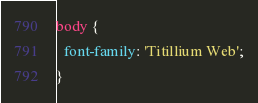Convert code to text. <code><loc_0><loc_0><loc_500><loc_500><_CSS_>body {
  font-family: 'Titillium Web';
}</code> 